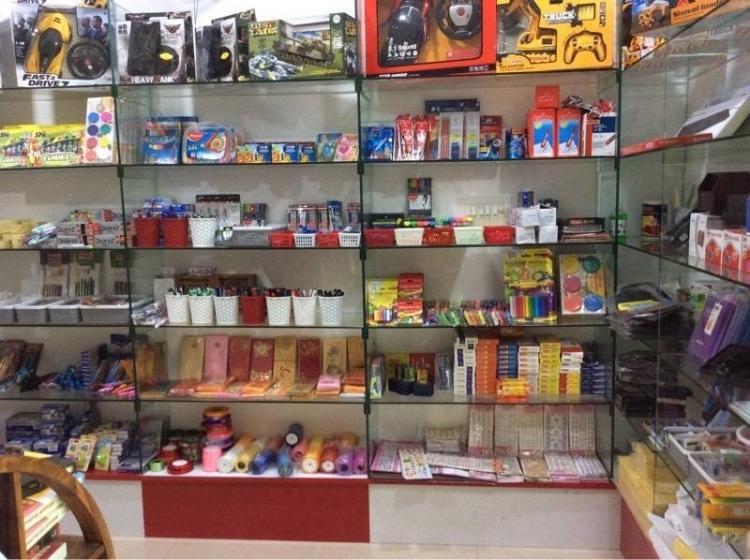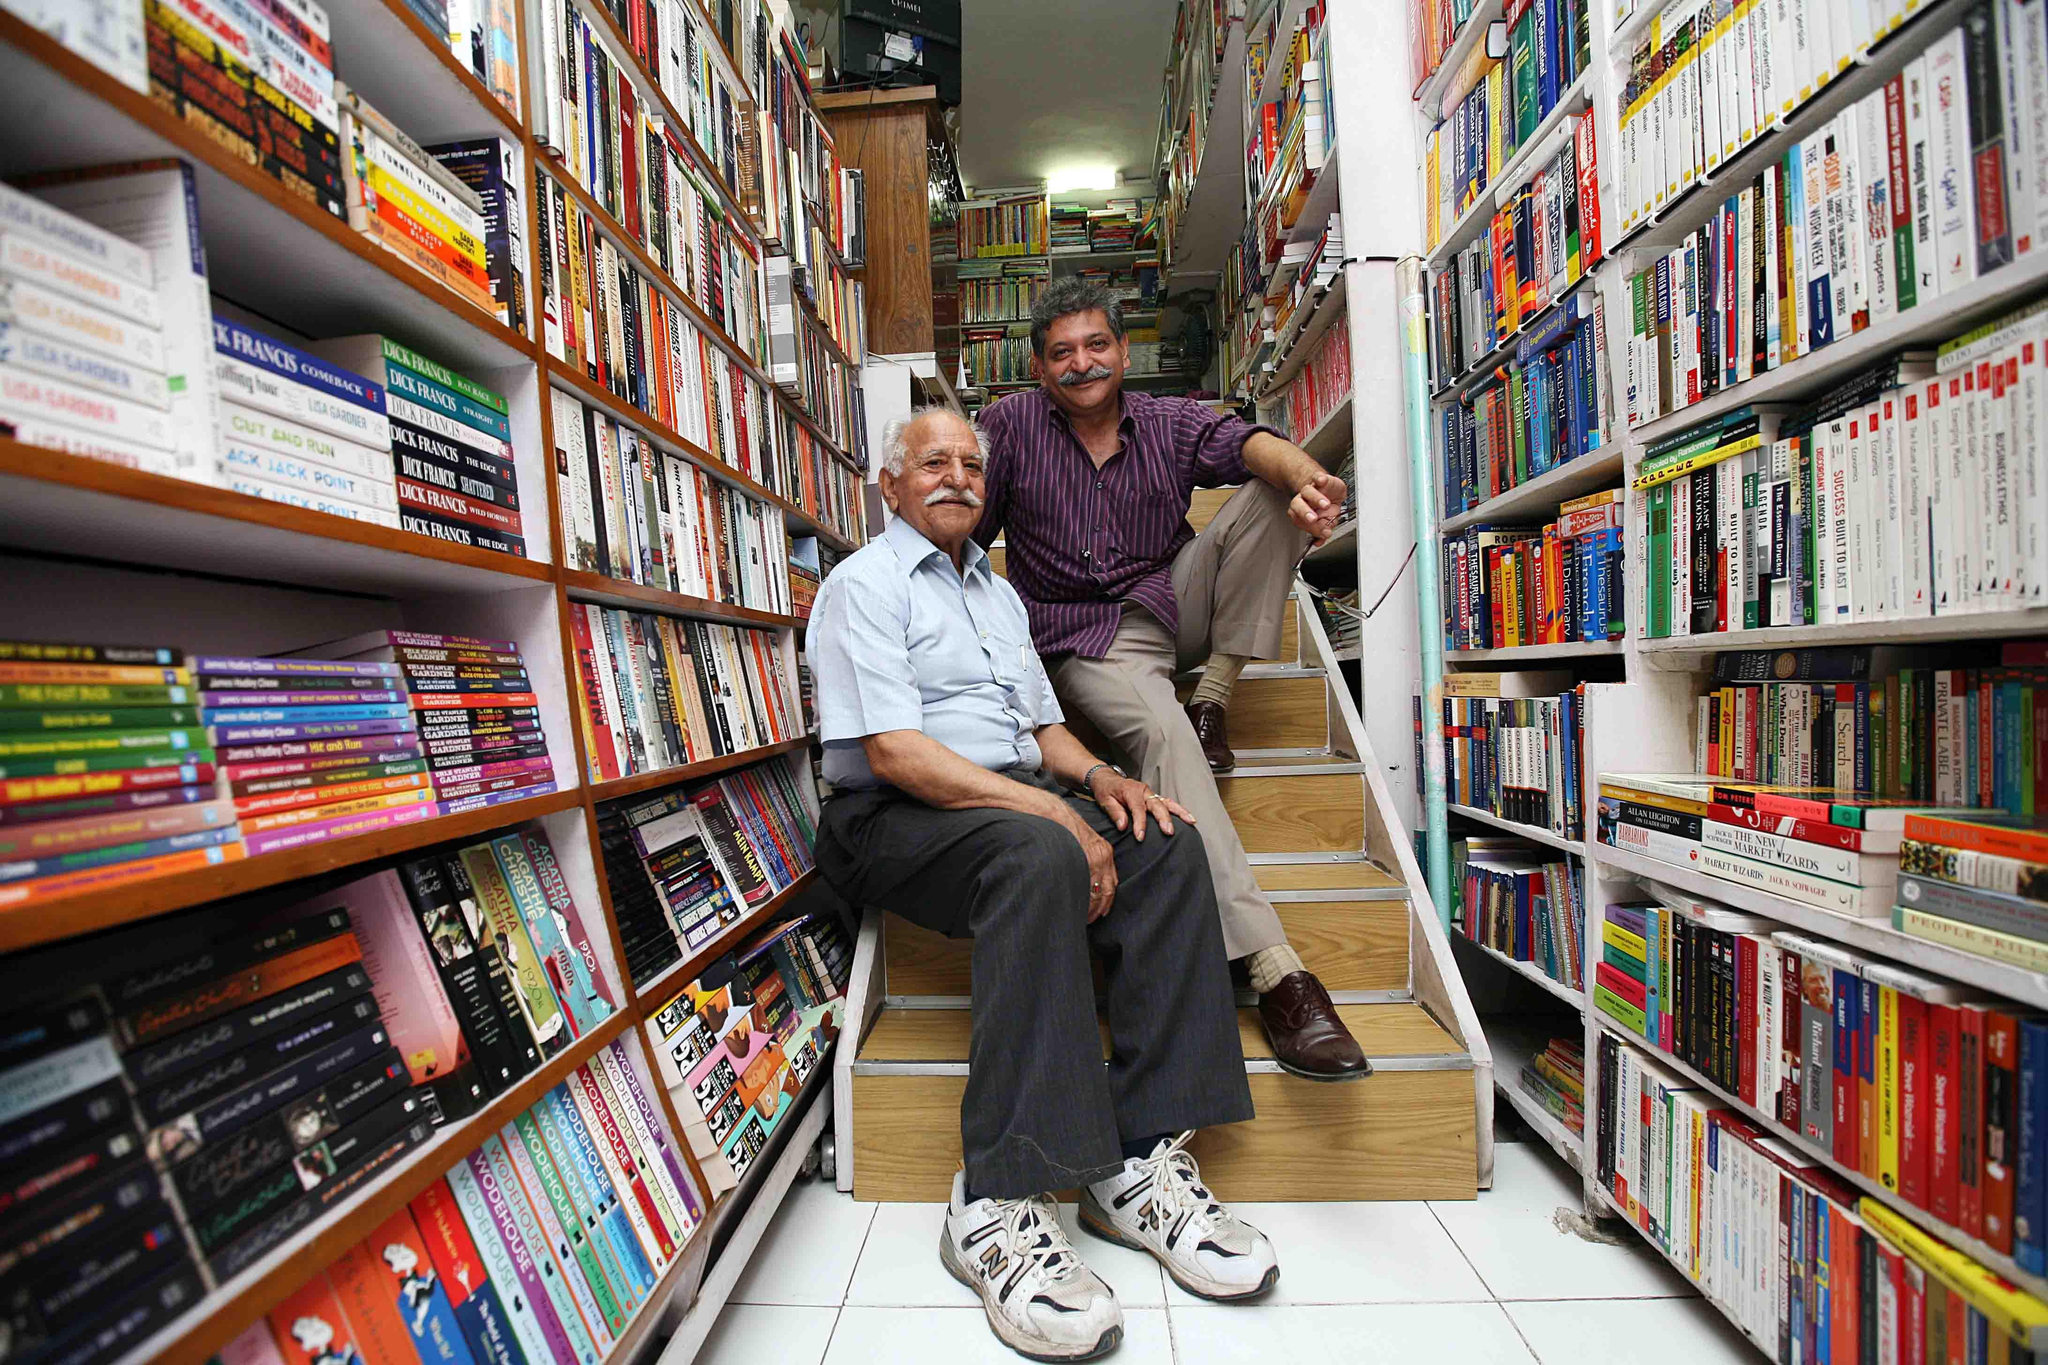The first image is the image on the left, the second image is the image on the right. Considering the images on both sides, is "There are people and books." valid? Answer yes or no. Yes. 